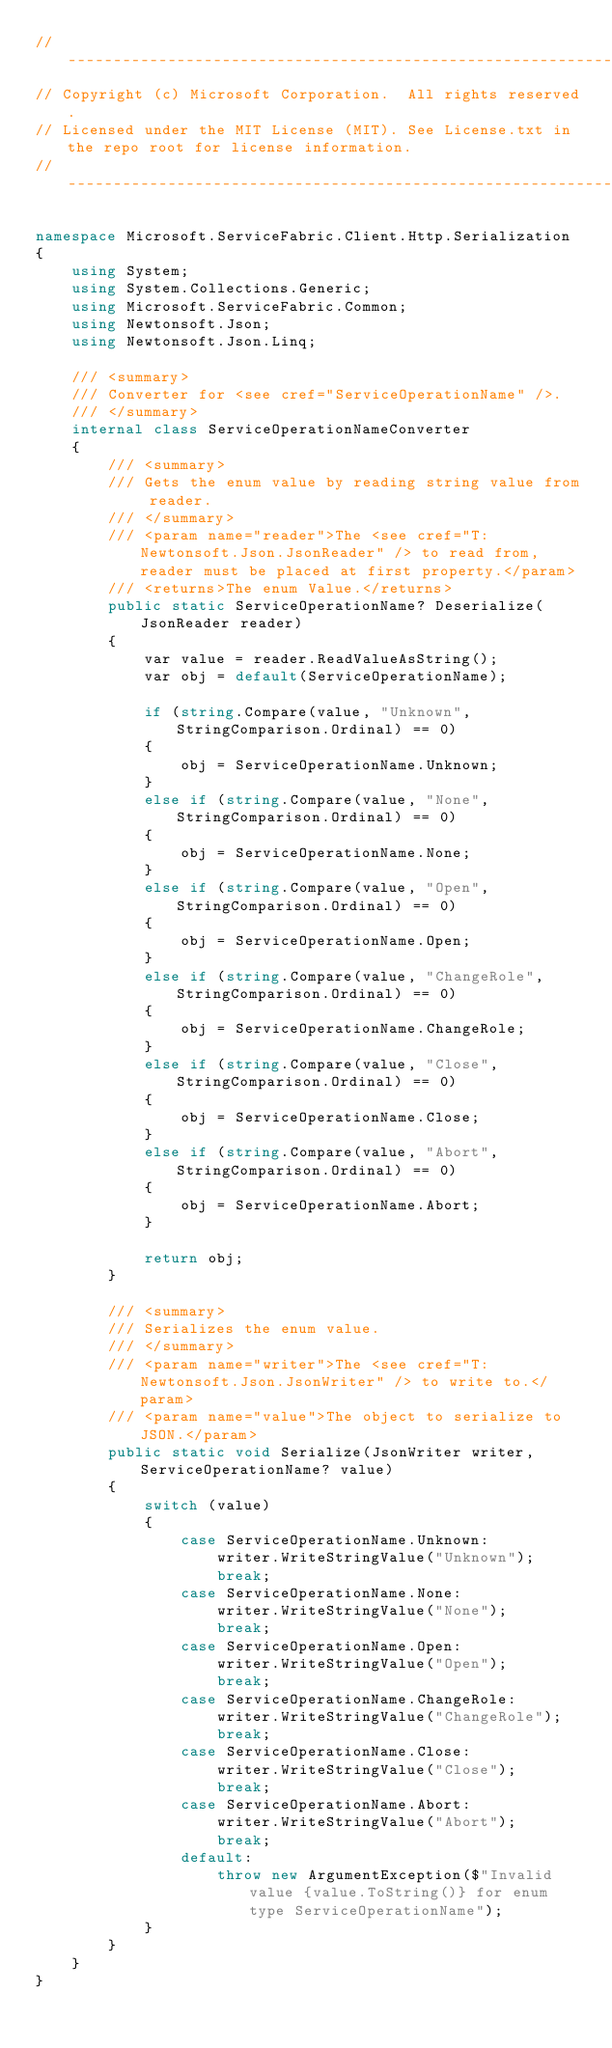<code> <loc_0><loc_0><loc_500><loc_500><_C#_>// ------------------------------------------------------------
// Copyright (c) Microsoft Corporation.  All rights reserved.
// Licensed under the MIT License (MIT). See License.txt in the repo root for license information.
// ------------------------------------------------------------

namespace Microsoft.ServiceFabric.Client.Http.Serialization
{
    using System;
    using System.Collections.Generic;
    using Microsoft.ServiceFabric.Common;
    using Newtonsoft.Json;
    using Newtonsoft.Json.Linq;

    /// <summary>
    /// Converter for <see cref="ServiceOperationName" />.
    /// </summary>
    internal class ServiceOperationNameConverter
    {
        /// <summary>
        /// Gets the enum value by reading string value from reader.
        /// </summary>
        /// <param name="reader">The <see cref="T: Newtonsoft.Json.JsonReader" /> to read from, reader must be placed at first property.</param>
        /// <returns>The enum Value.</returns>
        public static ServiceOperationName? Deserialize(JsonReader reader)
        {
            var value = reader.ReadValueAsString();
            var obj = default(ServiceOperationName);

            if (string.Compare(value, "Unknown", StringComparison.Ordinal) == 0)
            {
                obj = ServiceOperationName.Unknown;
            }
            else if (string.Compare(value, "None", StringComparison.Ordinal) == 0)
            {
                obj = ServiceOperationName.None;
            }
            else if (string.Compare(value, "Open", StringComparison.Ordinal) == 0)
            {
                obj = ServiceOperationName.Open;
            }
            else if (string.Compare(value, "ChangeRole", StringComparison.Ordinal) == 0)
            {
                obj = ServiceOperationName.ChangeRole;
            }
            else if (string.Compare(value, "Close", StringComparison.Ordinal) == 0)
            {
                obj = ServiceOperationName.Close;
            }
            else if (string.Compare(value, "Abort", StringComparison.Ordinal) == 0)
            {
                obj = ServiceOperationName.Abort;
            }

            return obj;
        }

        /// <summary>
        /// Serializes the enum value.
        /// </summary>
        /// <param name="writer">The <see cref="T: Newtonsoft.Json.JsonWriter" /> to write to.</param>
        /// <param name="value">The object to serialize to JSON.</param>
        public static void Serialize(JsonWriter writer, ServiceOperationName? value)
        {
            switch (value)
            {
                case ServiceOperationName.Unknown:
                    writer.WriteStringValue("Unknown");
                    break;
                case ServiceOperationName.None:
                    writer.WriteStringValue("None");
                    break;
                case ServiceOperationName.Open:
                    writer.WriteStringValue("Open");
                    break;
                case ServiceOperationName.ChangeRole:
                    writer.WriteStringValue("ChangeRole");
                    break;
                case ServiceOperationName.Close:
                    writer.WriteStringValue("Close");
                    break;
                case ServiceOperationName.Abort:
                    writer.WriteStringValue("Abort");
                    break;
                default:
                    throw new ArgumentException($"Invalid value {value.ToString()} for enum type ServiceOperationName");
            }
        }
    }
}
</code> 